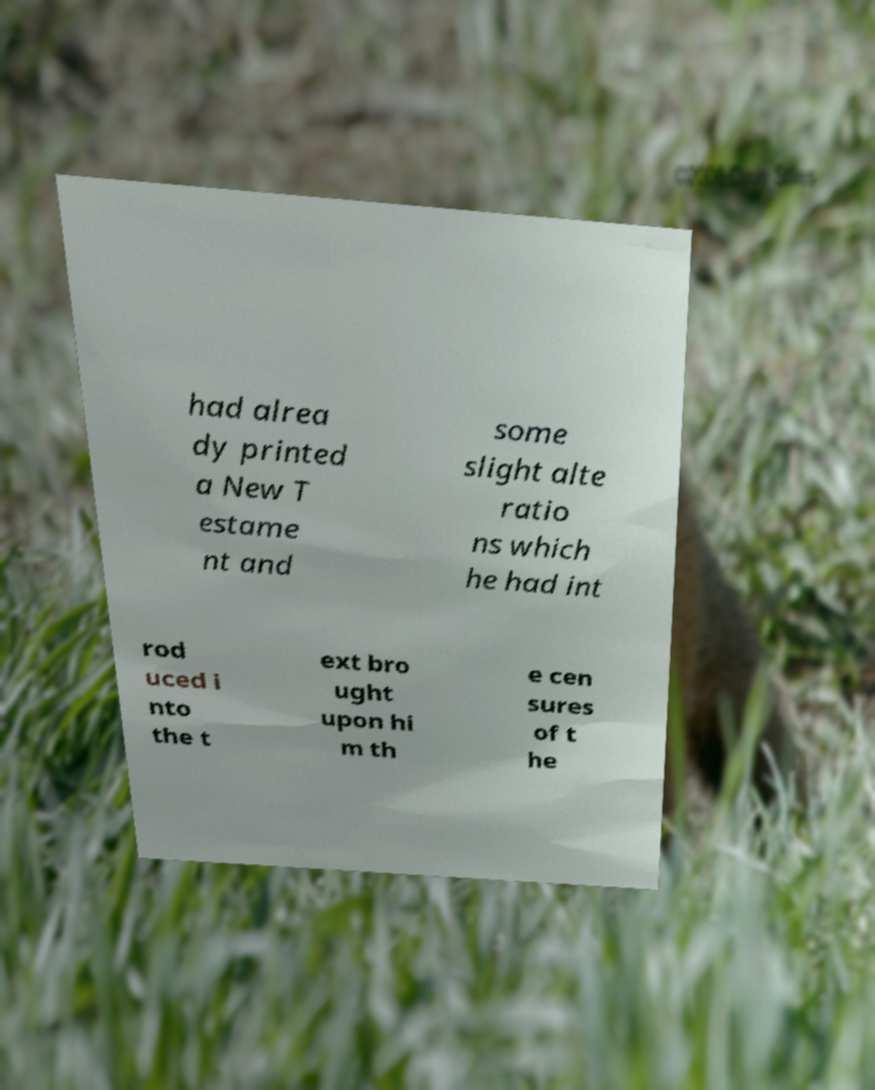Please read and relay the text visible in this image. What does it say? had alrea dy printed a New T estame nt and some slight alte ratio ns which he had int rod uced i nto the t ext bro ught upon hi m th e cen sures of t he 